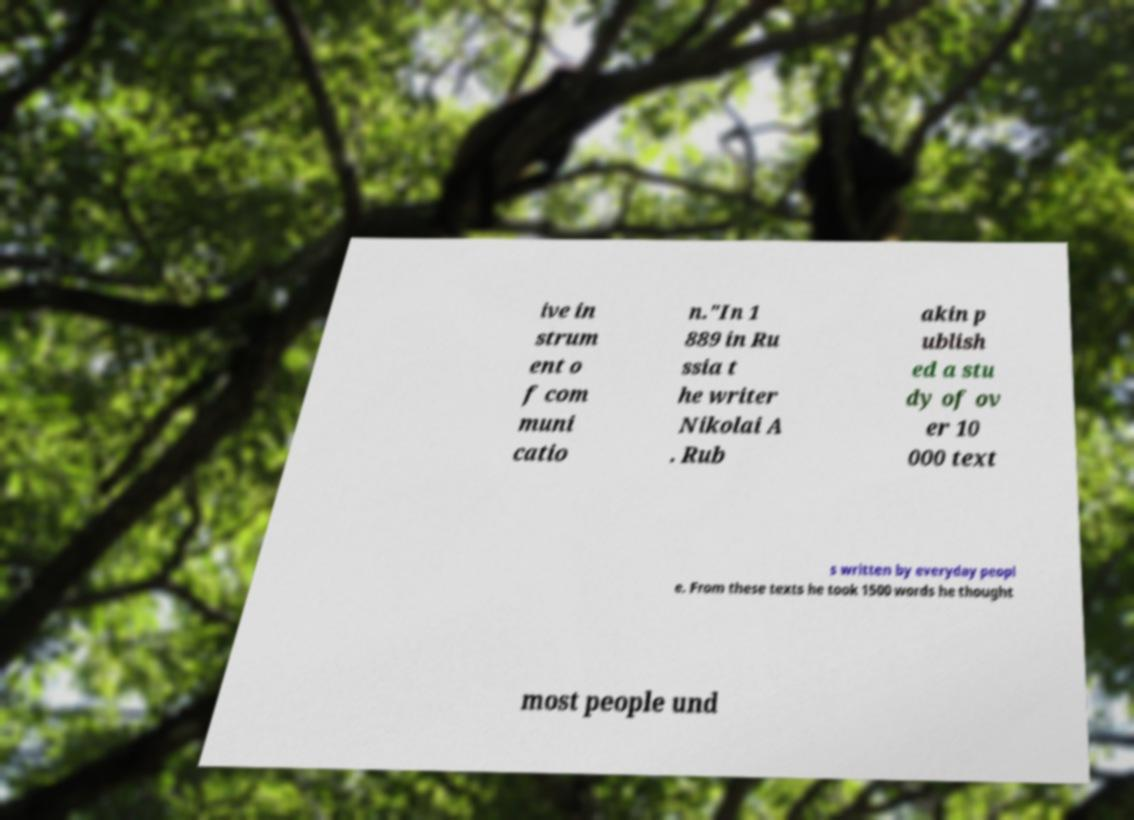Can you read and provide the text displayed in the image?This photo seems to have some interesting text. Can you extract and type it out for me? ive in strum ent o f com muni catio n."In 1 889 in Ru ssia t he writer Nikolai A . Rub akin p ublish ed a stu dy of ov er 10 000 text s written by everyday peopl e. From these texts he took 1500 words he thought most people und 